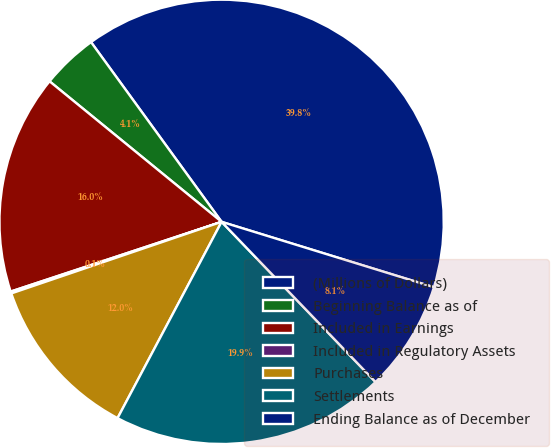Convert chart to OTSL. <chart><loc_0><loc_0><loc_500><loc_500><pie_chart><fcel>(Millions of Dollars)<fcel>Beginning Balance as of<fcel>Included in Earnings<fcel>Included in Regulatory Assets<fcel>Purchases<fcel>Settlements<fcel>Ending Balance as of December<nl><fcel>39.75%<fcel>4.1%<fcel>15.98%<fcel>0.14%<fcel>12.02%<fcel>19.94%<fcel>8.06%<nl></chart> 